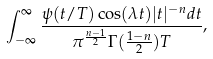Convert formula to latex. <formula><loc_0><loc_0><loc_500><loc_500>\int _ { - \infty } ^ { \infty } \frac { \psi ( t / T ) \cos ( \lambda t ) | t | ^ { - n } d t } { \pi ^ { \frac { n - 1 } { 2 } } \Gamma ( \frac { 1 - n } { 2 } ) T } ,</formula> 